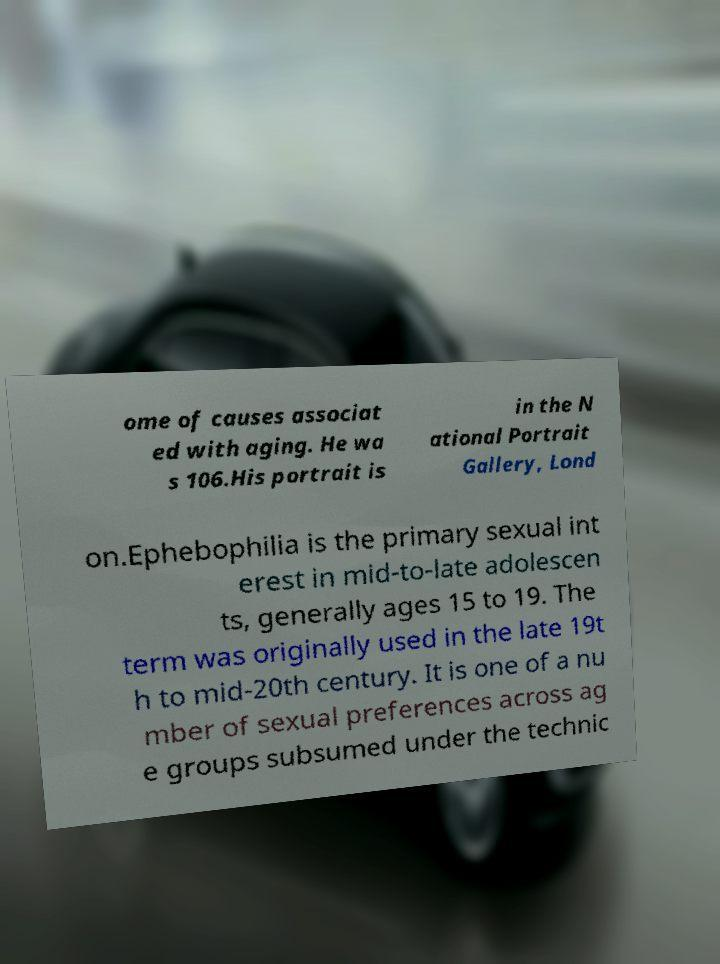Can you accurately transcribe the text from the provided image for me? ome of causes associat ed with aging. He wa s 106.His portrait is in the N ational Portrait Gallery, Lond on.Ephebophilia is the primary sexual int erest in mid-to-late adolescen ts, generally ages 15 to 19. The term was originally used in the late 19t h to mid-20th century. It is one of a nu mber of sexual preferences across ag e groups subsumed under the technic 